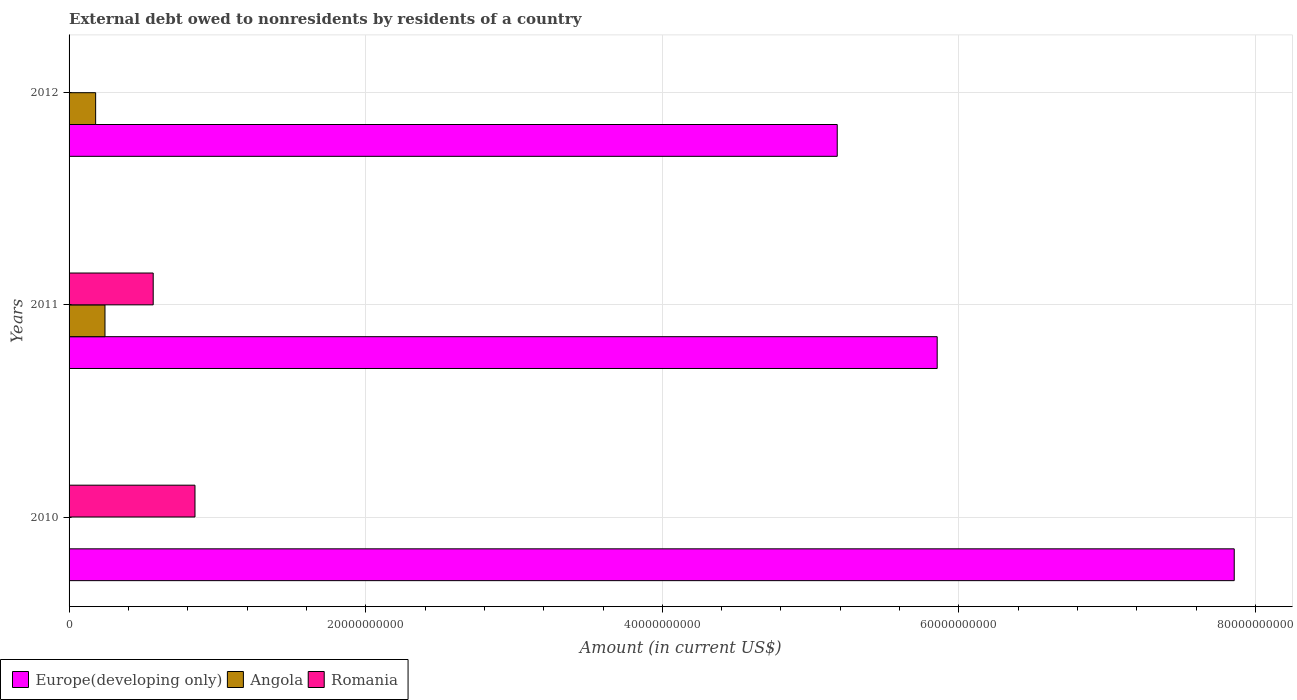How many groups of bars are there?
Your answer should be compact. 3. Are the number of bars per tick equal to the number of legend labels?
Your answer should be very brief. No. How many bars are there on the 1st tick from the top?
Offer a terse response. 2. How many bars are there on the 2nd tick from the bottom?
Ensure brevity in your answer.  3. In how many cases, is the number of bars for a given year not equal to the number of legend labels?
Offer a very short reply. 2. What is the external debt owed by residents in Angola in 2011?
Keep it short and to the point. 2.42e+09. Across all years, what is the maximum external debt owed by residents in Europe(developing only)?
Provide a short and direct response. 7.86e+1. Across all years, what is the minimum external debt owed by residents in Angola?
Your response must be concise. 0. In which year was the external debt owed by residents in Angola maximum?
Your response must be concise. 2011. What is the total external debt owed by residents in Angola in the graph?
Offer a very short reply. 4.21e+09. What is the difference between the external debt owed by residents in Europe(developing only) in 2010 and that in 2011?
Keep it short and to the point. 2.00e+1. What is the difference between the external debt owed by residents in Angola in 2011 and the external debt owed by residents in Europe(developing only) in 2012?
Offer a terse response. -4.94e+1. What is the average external debt owed by residents in Angola per year?
Keep it short and to the point. 1.40e+09. In the year 2011, what is the difference between the external debt owed by residents in Romania and external debt owed by residents in Europe(developing only)?
Ensure brevity in your answer.  -5.29e+1. In how many years, is the external debt owed by residents in Europe(developing only) greater than 4000000000 US$?
Your response must be concise. 3. What is the ratio of the external debt owed by residents in Europe(developing only) in 2010 to that in 2012?
Offer a very short reply. 1.52. What is the difference between the highest and the second highest external debt owed by residents in Europe(developing only)?
Give a very brief answer. 2.00e+1. What is the difference between the highest and the lowest external debt owed by residents in Romania?
Offer a terse response. 8.49e+09. How many bars are there?
Your response must be concise. 7. What is the difference between two consecutive major ticks on the X-axis?
Offer a terse response. 2.00e+1. Are the values on the major ticks of X-axis written in scientific E-notation?
Your response must be concise. No. Where does the legend appear in the graph?
Make the answer very short. Bottom left. How many legend labels are there?
Make the answer very short. 3. How are the legend labels stacked?
Your response must be concise. Horizontal. What is the title of the graph?
Ensure brevity in your answer.  External debt owed to nonresidents by residents of a country. Does "Northern Mariana Islands" appear as one of the legend labels in the graph?
Your response must be concise. No. What is the label or title of the X-axis?
Offer a terse response. Amount (in current US$). What is the Amount (in current US$) in Europe(developing only) in 2010?
Offer a terse response. 7.86e+1. What is the Amount (in current US$) in Angola in 2010?
Keep it short and to the point. 0. What is the Amount (in current US$) of Romania in 2010?
Offer a very short reply. 8.49e+09. What is the Amount (in current US$) in Europe(developing only) in 2011?
Your answer should be very brief. 5.85e+1. What is the Amount (in current US$) in Angola in 2011?
Your response must be concise. 2.42e+09. What is the Amount (in current US$) of Romania in 2011?
Your answer should be compact. 5.67e+09. What is the Amount (in current US$) of Europe(developing only) in 2012?
Your answer should be very brief. 5.18e+1. What is the Amount (in current US$) of Angola in 2012?
Keep it short and to the point. 1.79e+09. What is the Amount (in current US$) in Romania in 2012?
Your answer should be compact. 0. Across all years, what is the maximum Amount (in current US$) in Europe(developing only)?
Keep it short and to the point. 7.86e+1. Across all years, what is the maximum Amount (in current US$) of Angola?
Your answer should be very brief. 2.42e+09. Across all years, what is the maximum Amount (in current US$) of Romania?
Your response must be concise. 8.49e+09. Across all years, what is the minimum Amount (in current US$) of Europe(developing only)?
Make the answer very short. 5.18e+1. What is the total Amount (in current US$) of Europe(developing only) in the graph?
Provide a succinct answer. 1.89e+11. What is the total Amount (in current US$) in Angola in the graph?
Your answer should be compact. 4.21e+09. What is the total Amount (in current US$) in Romania in the graph?
Your response must be concise. 1.42e+1. What is the difference between the Amount (in current US$) in Europe(developing only) in 2010 and that in 2011?
Provide a short and direct response. 2.00e+1. What is the difference between the Amount (in current US$) of Romania in 2010 and that in 2011?
Offer a terse response. 2.82e+09. What is the difference between the Amount (in current US$) of Europe(developing only) in 2010 and that in 2012?
Offer a terse response. 2.68e+1. What is the difference between the Amount (in current US$) of Europe(developing only) in 2011 and that in 2012?
Keep it short and to the point. 6.74e+09. What is the difference between the Amount (in current US$) of Angola in 2011 and that in 2012?
Make the answer very short. 6.30e+08. What is the difference between the Amount (in current US$) of Europe(developing only) in 2010 and the Amount (in current US$) of Angola in 2011?
Provide a short and direct response. 7.61e+1. What is the difference between the Amount (in current US$) of Europe(developing only) in 2010 and the Amount (in current US$) of Romania in 2011?
Provide a succinct answer. 7.29e+1. What is the difference between the Amount (in current US$) of Europe(developing only) in 2010 and the Amount (in current US$) of Angola in 2012?
Give a very brief answer. 7.68e+1. What is the difference between the Amount (in current US$) of Europe(developing only) in 2011 and the Amount (in current US$) of Angola in 2012?
Make the answer very short. 5.67e+1. What is the average Amount (in current US$) of Europe(developing only) per year?
Provide a succinct answer. 6.30e+1. What is the average Amount (in current US$) in Angola per year?
Your answer should be compact. 1.40e+09. What is the average Amount (in current US$) of Romania per year?
Give a very brief answer. 4.72e+09. In the year 2010, what is the difference between the Amount (in current US$) of Europe(developing only) and Amount (in current US$) of Romania?
Keep it short and to the point. 7.01e+1. In the year 2011, what is the difference between the Amount (in current US$) of Europe(developing only) and Amount (in current US$) of Angola?
Provide a short and direct response. 5.61e+1. In the year 2011, what is the difference between the Amount (in current US$) of Europe(developing only) and Amount (in current US$) of Romania?
Provide a short and direct response. 5.29e+1. In the year 2011, what is the difference between the Amount (in current US$) in Angola and Amount (in current US$) in Romania?
Offer a terse response. -3.25e+09. In the year 2012, what is the difference between the Amount (in current US$) in Europe(developing only) and Amount (in current US$) in Angola?
Your answer should be very brief. 5.00e+1. What is the ratio of the Amount (in current US$) of Europe(developing only) in 2010 to that in 2011?
Your answer should be very brief. 1.34. What is the ratio of the Amount (in current US$) of Romania in 2010 to that in 2011?
Your response must be concise. 1.5. What is the ratio of the Amount (in current US$) in Europe(developing only) in 2010 to that in 2012?
Give a very brief answer. 1.52. What is the ratio of the Amount (in current US$) of Europe(developing only) in 2011 to that in 2012?
Make the answer very short. 1.13. What is the ratio of the Amount (in current US$) of Angola in 2011 to that in 2012?
Give a very brief answer. 1.35. What is the difference between the highest and the second highest Amount (in current US$) of Europe(developing only)?
Make the answer very short. 2.00e+1. What is the difference between the highest and the lowest Amount (in current US$) in Europe(developing only)?
Give a very brief answer. 2.68e+1. What is the difference between the highest and the lowest Amount (in current US$) in Angola?
Your response must be concise. 2.42e+09. What is the difference between the highest and the lowest Amount (in current US$) of Romania?
Provide a succinct answer. 8.49e+09. 